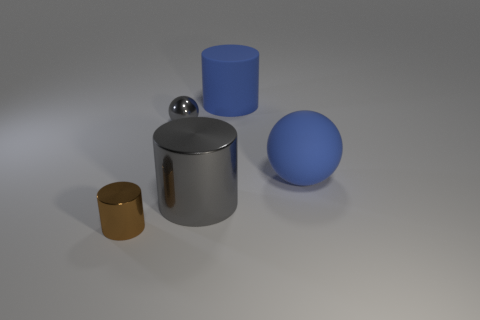There is a thing that is to the right of the large metal object and on the left side of the big rubber ball; what is its size?
Keep it short and to the point. Large. There is a large shiny object; is it the same color as the sphere on the left side of the large gray metallic cylinder?
Ensure brevity in your answer.  Yes. What number of yellow things are either big objects or big metal objects?
Your answer should be very brief. 0. The tiny brown object is what shape?
Give a very brief answer. Cylinder. How many other objects are there of the same shape as the brown thing?
Your response must be concise. 2. What is the color of the metal object behind the big blue rubber sphere?
Your answer should be very brief. Gray. Are the small brown thing and the gray ball made of the same material?
Provide a succinct answer. Yes. How many objects are matte cylinders or big blue rubber things that are behind the big blue rubber sphere?
Provide a short and direct response. 1. There is a cylinder that is the same color as the large rubber sphere; what is its size?
Ensure brevity in your answer.  Large. What shape is the big rubber object that is in front of the small gray object?
Your answer should be very brief. Sphere. 